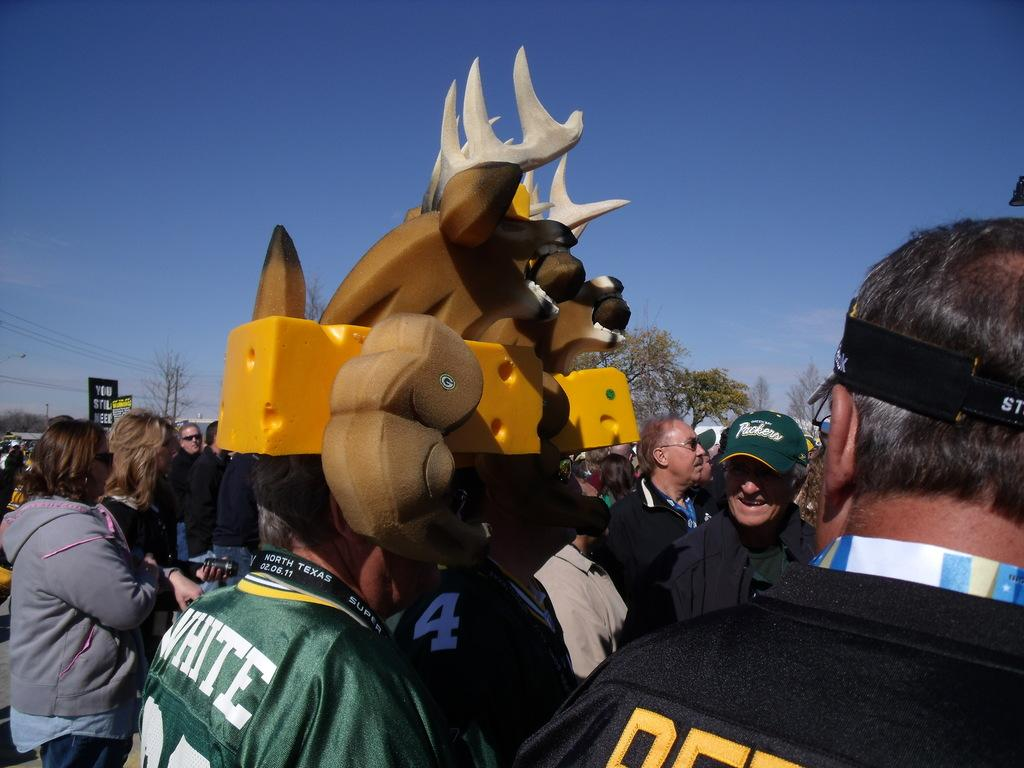What are the people in the image doing? The people in the image are standing on the road. What are some of the people holding on their heads? Some people are holding objects on their heads. What can be seen in the background of the image? The background of the image includes sky, trees, information boards, poles, and cables. What time of day is it in the image, considering the presence of chickens? There are no chickens present in the image, so it is not possible to determine the time of day based on their presence. 